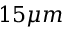<formula> <loc_0><loc_0><loc_500><loc_500>1 5 \mu m</formula> 